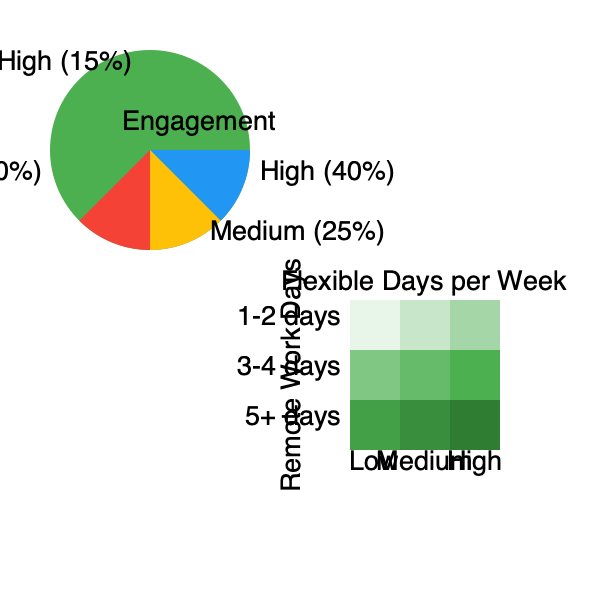Based on the pie chart and heat map provided, what conclusion can be drawn about the relationship between flexible work arrangements and employee engagement, and how might this information influence strategic decision-making regarding employee benefits? To answer this question, we need to analyze both the pie chart and the heat map:

1. Pie Chart Analysis:
   - The pie chart shows the distribution of employee engagement levels.
   - 40% of employees have high engagement.
   - 25% have medium engagement.
   - 20% have low engagement.
   - 15% have very high engagement.
   - Combined, 55% of employees (40% high + 15% very high) have above-average engagement.

2. Heat Map Analysis:
   - The heat map shows the relationship between remote work days and flexible days per week.
   - Darker green colors indicate higher engagement levels.
   - The darkest green (highest engagement) is in the bottom right corner, representing 5+ remote work days and high flexibility.
   - There's a general trend of increasing engagement (darker colors) as both remote work days and flexible days increase.

3. Relationship between flexible work and engagement:
   - The heat map suggests that increased flexibility and remote work options correlate with higher engagement levels.
   - This aligns with the pie chart, where a majority of employees (55%) show high or very high engagement.

4. Strategic decision-making implications:
   - The data suggests that offering more flexible work arrangements could lead to higher employee engagement.
   - Higher engagement is often associated with increased productivity, retention, and overall company success.
   - As a CEO viewing employee benefits as a strategic investment, this data supports expanding flexible work options.
   - Implementing or increasing flexible work policies could be a cost-effective way to boost engagement and potentially improve company performance.

5. Considerations for implementation:
   - While the data shows a positive trend, it's important to consider other factors such as job roles, team dynamics, and individual preferences.
   - A phased approach to implementing more flexible arrangements might be prudent to assess the impact on different departments or teams.
   - Regular monitoring and feedback collection would be crucial to ensure the strategy is effective across the organization.
Answer: Flexible work arrangements positively correlate with employee engagement, suggesting that expanding these options could be a strategic investment to improve company performance through increased employee satisfaction and productivity. 